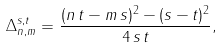<formula> <loc_0><loc_0><loc_500><loc_500>\Delta ^ { s , t } _ { n , m } = \frac { ( n \, t - m \, s ) ^ { 2 } - ( s - t ) ^ { 2 } } { 4 \, s \, t } ,</formula> 